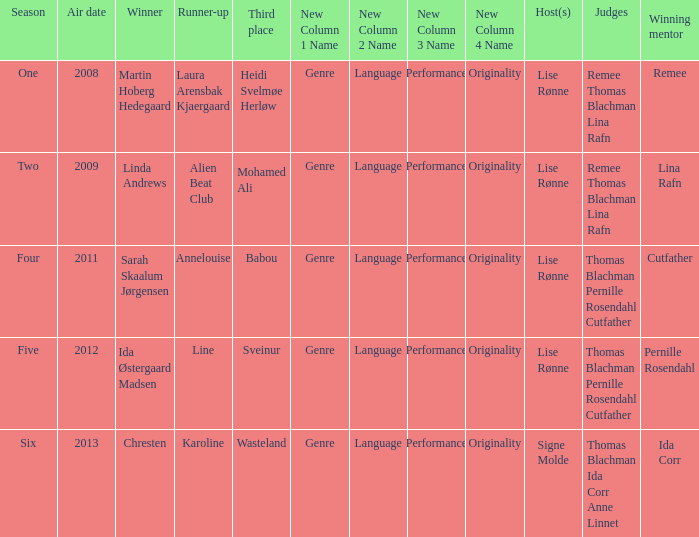Which season did Ida Corr win? Six. Can you parse all the data within this table? {'header': ['Season', 'Air date', 'Winner', 'Runner-up', 'Third place', 'New Column 1 Name', 'New Column 2 Name', 'New Column 3 Name', 'New Column 4 Name', 'Host(s)', 'Judges', 'Winning mentor'], 'rows': [['One', '2008', 'Martin Hoberg Hedegaard', 'Laura Arensbak Kjaergaard', 'Heidi Svelmøe Herløw', 'Genre', 'Language', 'Performance', 'Originality', 'Lise Rønne', 'Remee Thomas Blachman Lina Rafn', 'Remee'], ['Two', '2009', 'Linda Andrews', 'Alien Beat Club', 'Mohamed Ali', 'Genre', 'Language', 'Performance', 'Originality', 'Lise Rønne', 'Remee Thomas Blachman Lina Rafn', 'Lina Rafn'], ['Four', '2011', 'Sarah Skaalum Jørgensen', 'Annelouise', 'Babou', 'Genre', 'Language', 'Performance', 'Originality', 'Lise Rønne', 'Thomas Blachman Pernille Rosendahl Cutfather', 'Cutfather'], ['Five', '2012', 'Ida Østergaard Madsen', 'Line', 'Sveinur', 'Genre', 'Language', 'Performance', 'Originality', 'Lise Rønne', 'Thomas Blachman Pernille Rosendahl Cutfather', 'Pernille Rosendahl'], ['Six', '2013', 'Chresten', 'Karoline', 'Wasteland', 'Genre', 'Language', 'Performance', 'Originality', 'Signe Molde', 'Thomas Blachman Ida Corr Anne Linnet', 'Ida Corr']]} 